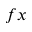<formula> <loc_0><loc_0><loc_500><loc_500>f x</formula> 